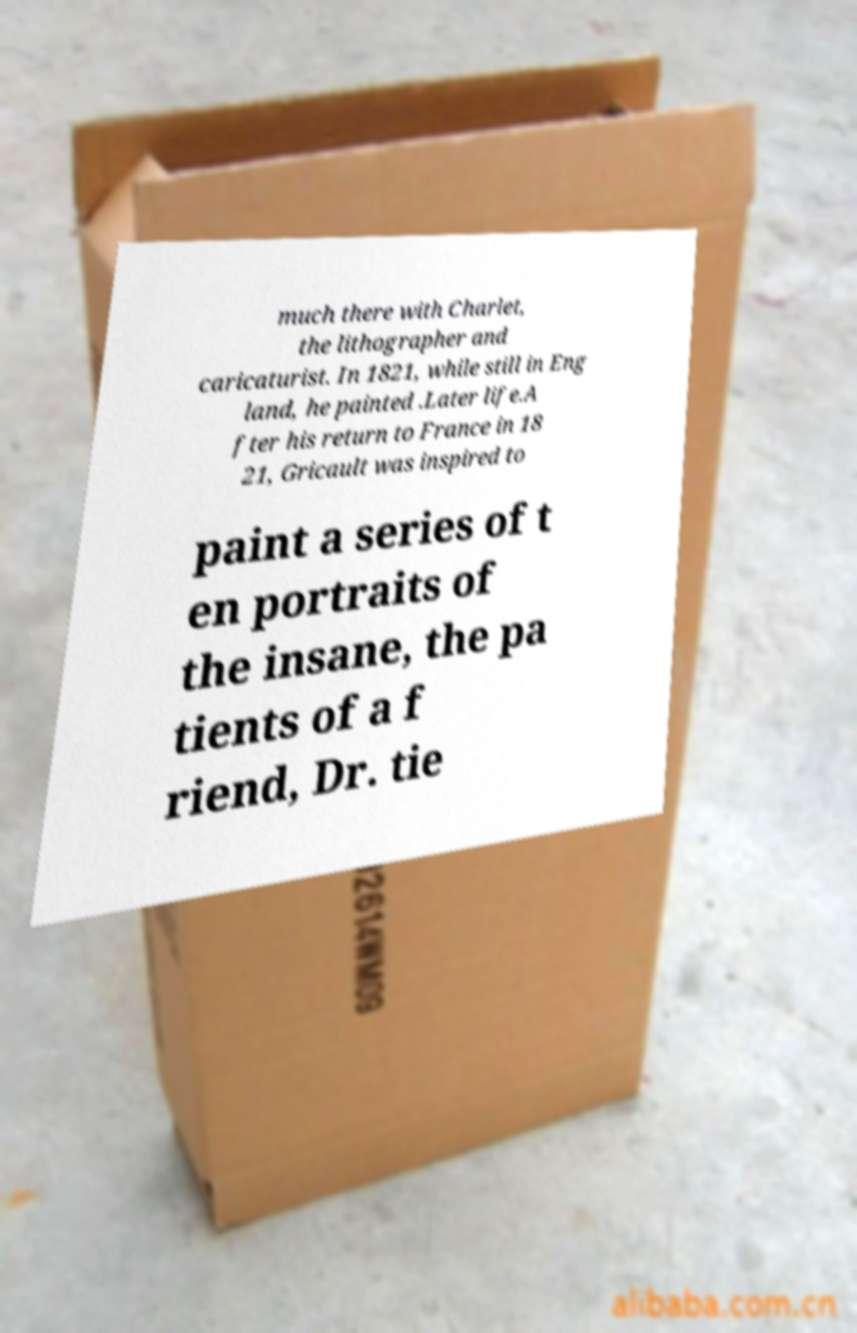For documentation purposes, I need the text within this image transcribed. Could you provide that? much there with Charlet, the lithographer and caricaturist. In 1821, while still in Eng land, he painted .Later life.A fter his return to France in 18 21, Gricault was inspired to paint a series of t en portraits of the insane, the pa tients of a f riend, Dr. tie 